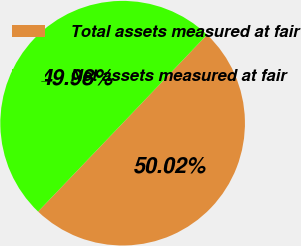Convert chart. <chart><loc_0><loc_0><loc_500><loc_500><pie_chart><fcel>Total assets measured at fair<fcel>Net assets measured at fair<nl><fcel>50.02%<fcel>49.98%<nl></chart> 